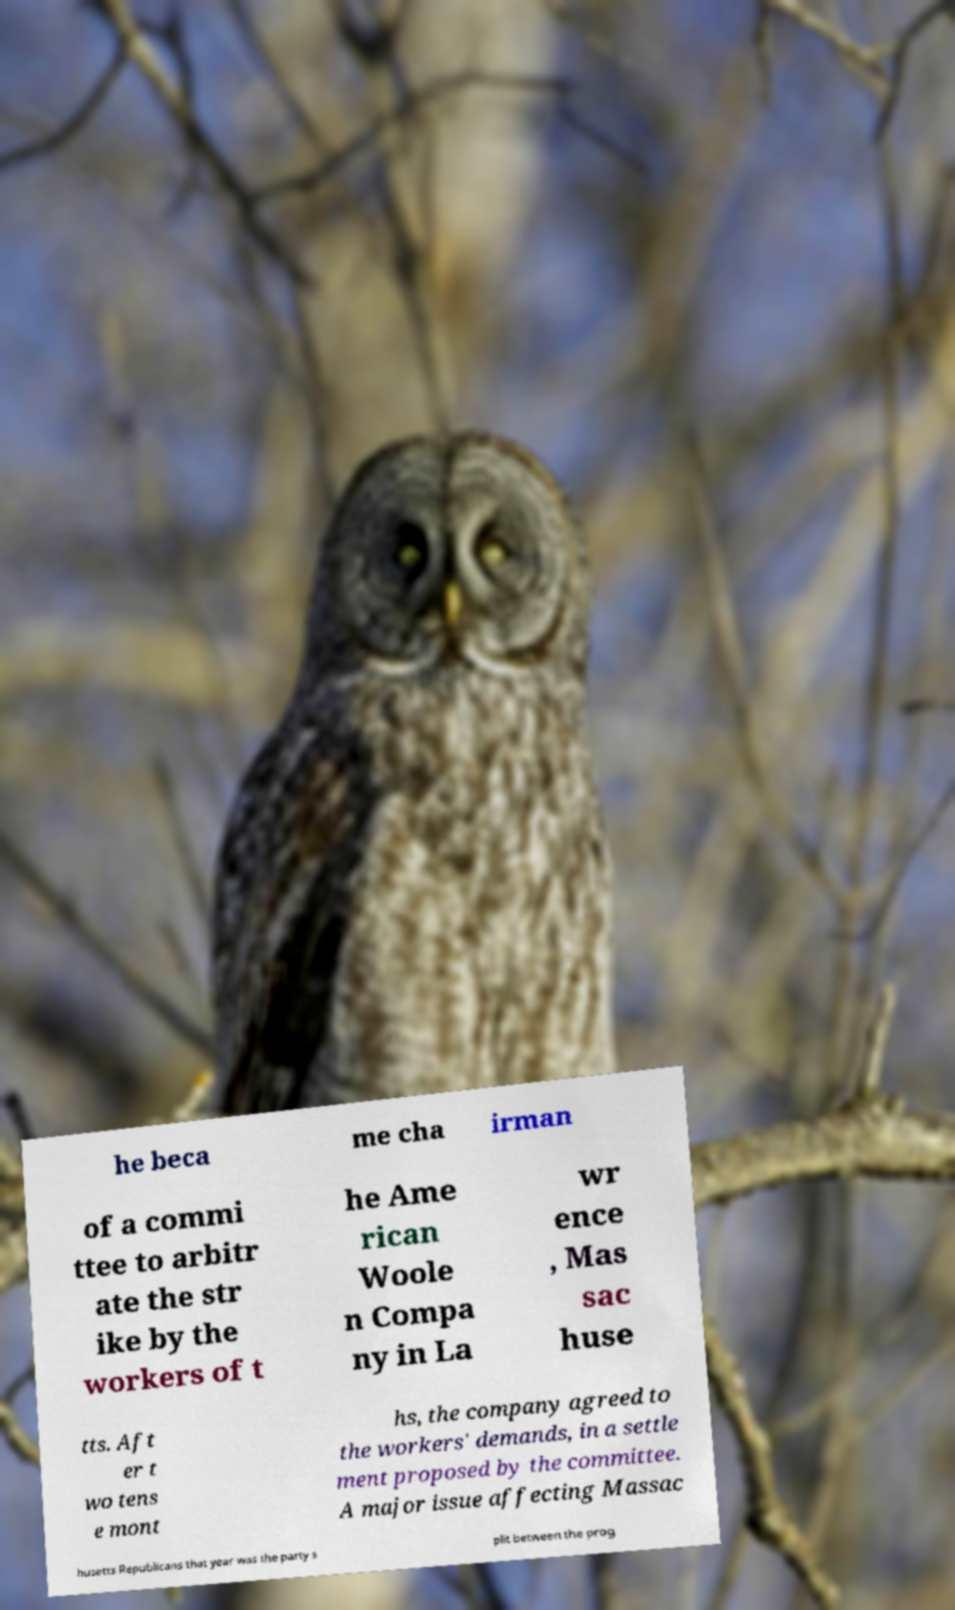Can you read and provide the text displayed in the image?This photo seems to have some interesting text. Can you extract and type it out for me? he beca me cha irman of a commi ttee to arbitr ate the str ike by the workers of t he Ame rican Woole n Compa ny in La wr ence , Mas sac huse tts. Aft er t wo tens e mont hs, the company agreed to the workers' demands, in a settle ment proposed by the committee. A major issue affecting Massac husetts Republicans that year was the party s plit between the prog 